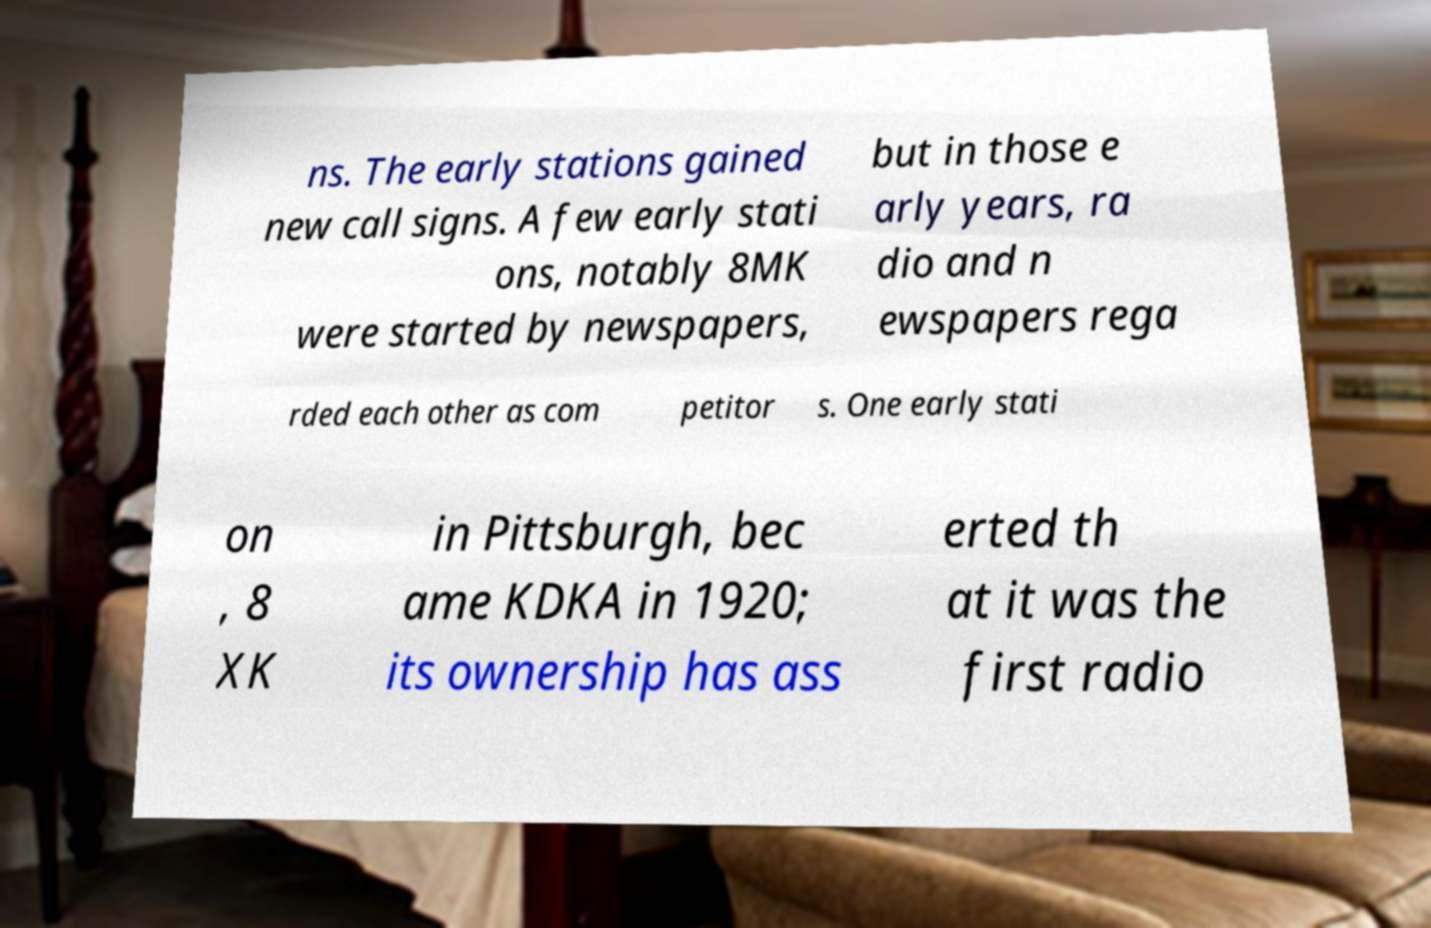Please read and relay the text visible in this image. What does it say? ns. The early stations gained new call signs. A few early stati ons, notably 8MK were started by newspapers, but in those e arly years, ra dio and n ewspapers rega rded each other as com petitor s. One early stati on , 8 XK in Pittsburgh, bec ame KDKA in 1920; its ownership has ass erted th at it was the first radio 